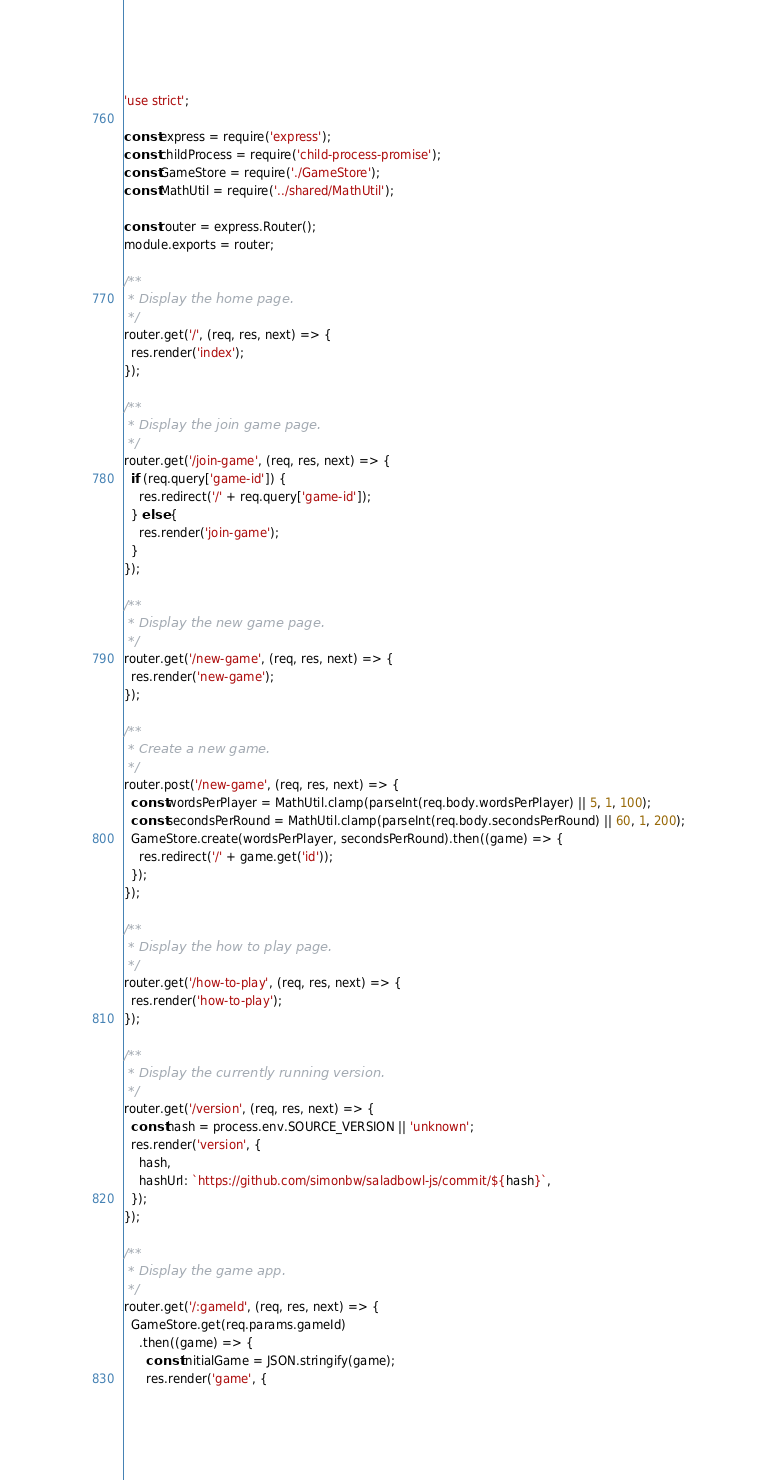<code> <loc_0><loc_0><loc_500><loc_500><_JavaScript_>'use strict';

const express = require('express');
const childProcess = require('child-process-promise');
const GameStore = require('./GameStore');
const MathUtil = require('../shared/MathUtil');

const router = express.Router();
module.exports = router;

/**
 * Display the home page.
 */
router.get('/', (req, res, next) => {
  res.render('index');
});

/**
 * Display the join game page.
 */
router.get('/join-game', (req, res, next) => {
  if (req.query['game-id']) {
    res.redirect('/' + req.query['game-id']);
  } else {
    res.render('join-game');
  }
});

/**
 * Display the new game page.
 */
router.get('/new-game', (req, res, next) => {
  res.render('new-game');
});

/**
 * Create a new game.
 */
router.post('/new-game', (req, res, next) => {
  const wordsPerPlayer = MathUtil.clamp(parseInt(req.body.wordsPerPlayer) || 5, 1, 100);
  const secondsPerRound = MathUtil.clamp(parseInt(req.body.secondsPerRound) || 60, 1, 200);
  GameStore.create(wordsPerPlayer, secondsPerRound).then((game) => {
    res.redirect('/' + game.get('id'));
  });
});

/**
 * Display the how to play page.
 */
router.get('/how-to-play', (req, res, next) => {
  res.render('how-to-play');
});

/**
 * Display the currently running version.
 */
router.get('/version', (req, res, next) => {
  const hash = process.env.SOURCE_VERSION || 'unknown';
  res.render('version', {
    hash,
    hashUrl: `https://github.com/simonbw/saladbowl-js/commit/${hash}`,
  });
});

/**
 * Display the game app.
 */
router.get('/:gameId', (req, res, next) => {
  GameStore.get(req.params.gameId)
    .then((game) => {
      const initialGame = JSON.stringify(game);
      res.render('game', {</code> 